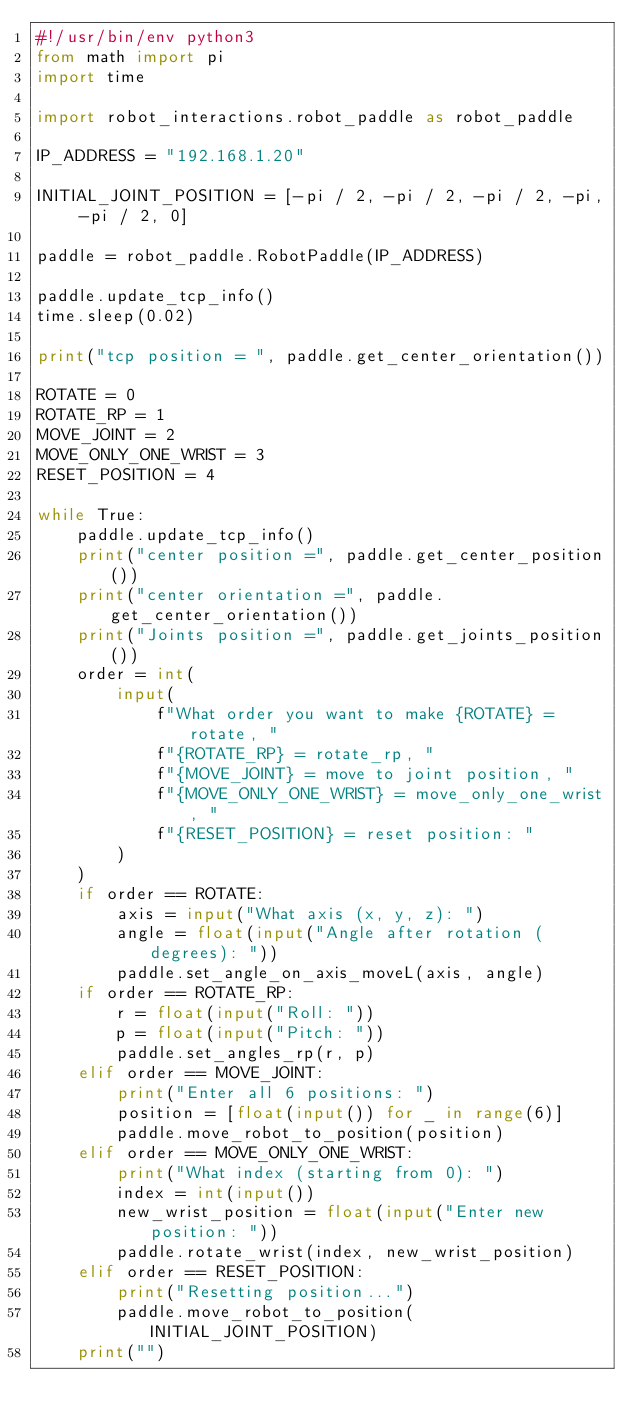Convert code to text. <code><loc_0><loc_0><loc_500><loc_500><_Python_>#!/usr/bin/env python3
from math import pi
import time

import robot_interactions.robot_paddle as robot_paddle

IP_ADDRESS = "192.168.1.20"

INITIAL_JOINT_POSITION = [-pi / 2, -pi / 2, -pi / 2, -pi, -pi / 2, 0]

paddle = robot_paddle.RobotPaddle(IP_ADDRESS)

paddle.update_tcp_info()
time.sleep(0.02)

print("tcp position = ", paddle.get_center_orientation())

ROTATE = 0
ROTATE_RP = 1
MOVE_JOINT = 2
MOVE_ONLY_ONE_WRIST = 3
RESET_POSITION = 4

while True:
    paddle.update_tcp_info()
    print("center position =", paddle.get_center_position())
    print("center orientation =", paddle.get_center_orientation())
    print("Joints position =", paddle.get_joints_position())
    order = int(
        input(
            f"What order you want to make {ROTATE} = rotate, "
            f"{ROTATE_RP} = rotate_rp, "
            f"{MOVE_JOINT} = move to joint position, "
            f"{MOVE_ONLY_ONE_WRIST} = move_only_one_wrist, "
            f"{RESET_POSITION} = reset position: "
        )
    )
    if order == ROTATE:
        axis = input("What axis (x, y, z): ")
        angle = float(input("Angle after rotation (degrees): "))
        paddle.set_angle_on_axis_moveL(axis, angle)
    if order == ROTATE_RP:
        r = float(input("Roll: "))
        p = float(input("Pitch: "))
        paddle.set_angles_rp(r, p)
    elif order == MOVE_JOINT:
        print("Enter all 6 positions: ")
        position = [float(input()) for _ in range(6)]
        paddle.move_robot_to_position(position)
    elif order == MOVE_ONLY_ONE_WRIST:
        print("What index (starting from 0): ")
        index = int(input())
        new_wrist_position = float(input("Enter new position: "))
        paddle.rotate_wrist(index, new_wrist_position)
    elif order == RESET_POSITION:
        print("Resetting position...")
        paddle.move_robot_to_position(INITIAL_JOINT_POSITION)
    print("")
</code> 